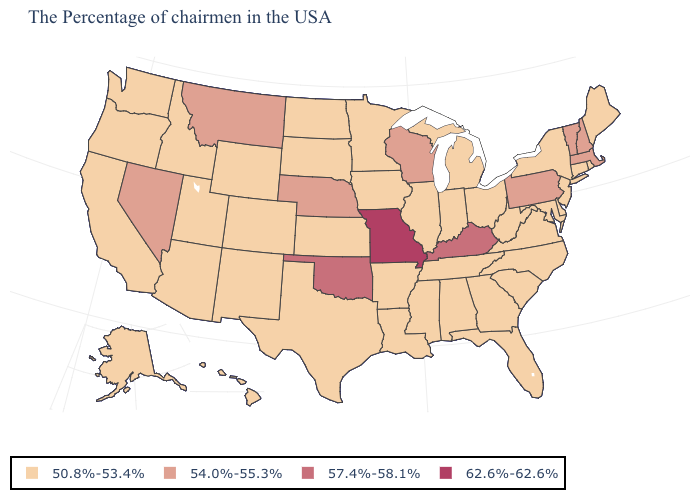How many symbols are there in the legend?
Quick response, please. 4. What is the value of Arizona?
Be succinct. 50.8%-53.4%. Among the states that border Virginia , which have the highest value?
Write a very short answer. Kentucky. What is the value of Wisconsin?
Answer briefly. 54.0%-55.3%. What is the lowest value in states that border Texas?
Quick response, please. 50.8%-53.4%. Does Virginia have a lower value than Massachusetts?
Short answer required. Yes. Does the map have missing data?
Quick response, please. No. Does Louisiana have the highest value in the South?
Give a very brief answer. No. Which states have the lowest value in the Northeast?
Short answer required. Maine, Rhode Island, Connecticut, New York, New Jersey. What is the value of Florida?
Write a very short answer. 50.8%-53.4%. Which states hav the highest value in the MidWest?
Give a very brief answer. Missouri. What is the value of Oregon?
Write a very short answer. 50.8%-53.4%. What is the value of Alaska?
Quick response, please. 50.8%-53.4%. Name the states that have a value in the range 57.4%-58.1%?
Short answer required. Kentucky, Oklahoma. What is the highest value in the USA?
Concise answer only. 62.6%-62.6%. 